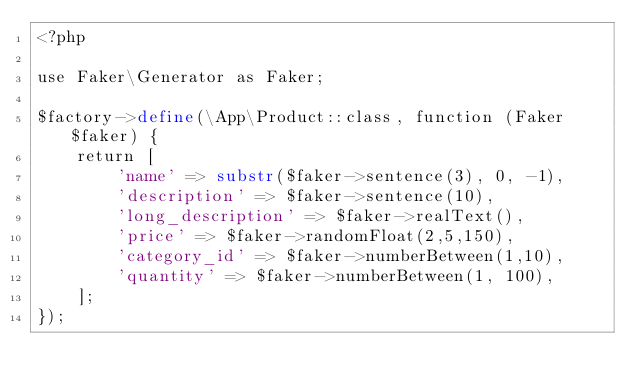<code> <loc_0><loc_0><loc_500><loc_500><_PHP_><?php

use Faker\Generator as Faker;

$factory->define(\App\Product::class, function (Faker $faker) {
    return [
        'name' => substr($faker->sentence(3), 0, -1),
        'description' => $faker->sentence(10),
        'long_description' => $faker->realText(),
        'price' => $faker->randomFloat(2,5,150),
        'category_id' => $faker->numberBetween(1,10),
        'quantity' => $faker->numberBetween(1, 100),
    ];
});
</code> 